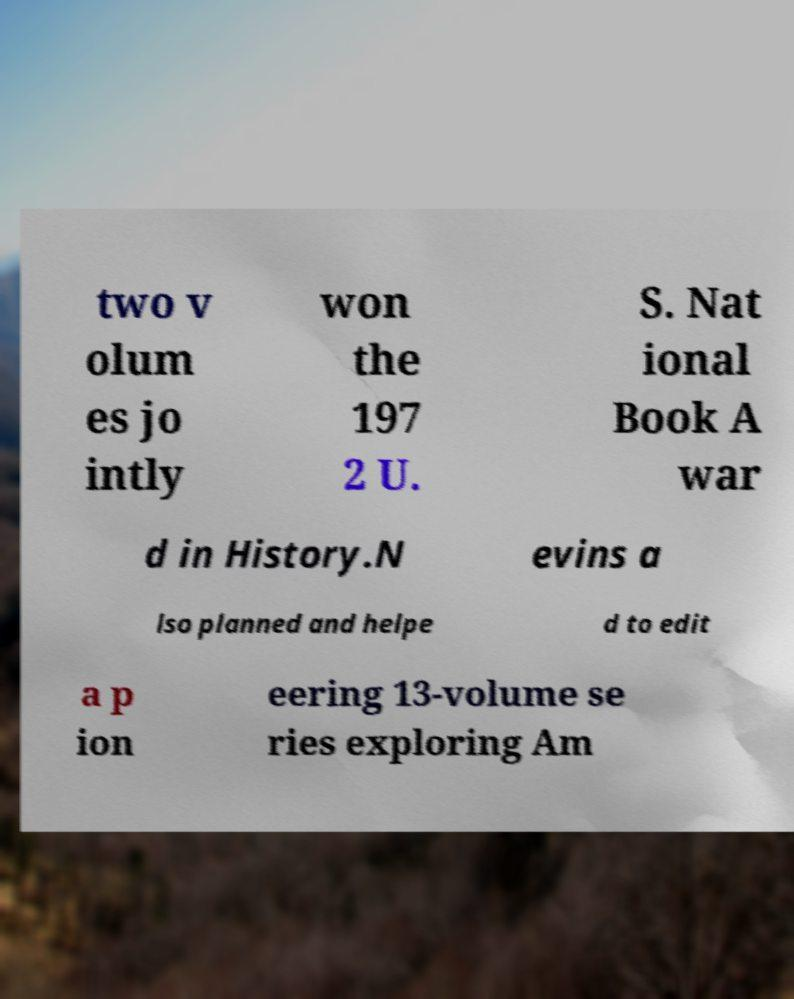What messages or text are displayed in this image? I need them in a readable, typed format. two v olum es jo intly won the 197 2 U. S. Nat ional Book A war d in History.N evins a lso planned and helpe d to edit a p ion eering 13-volume se ries exploring Am 